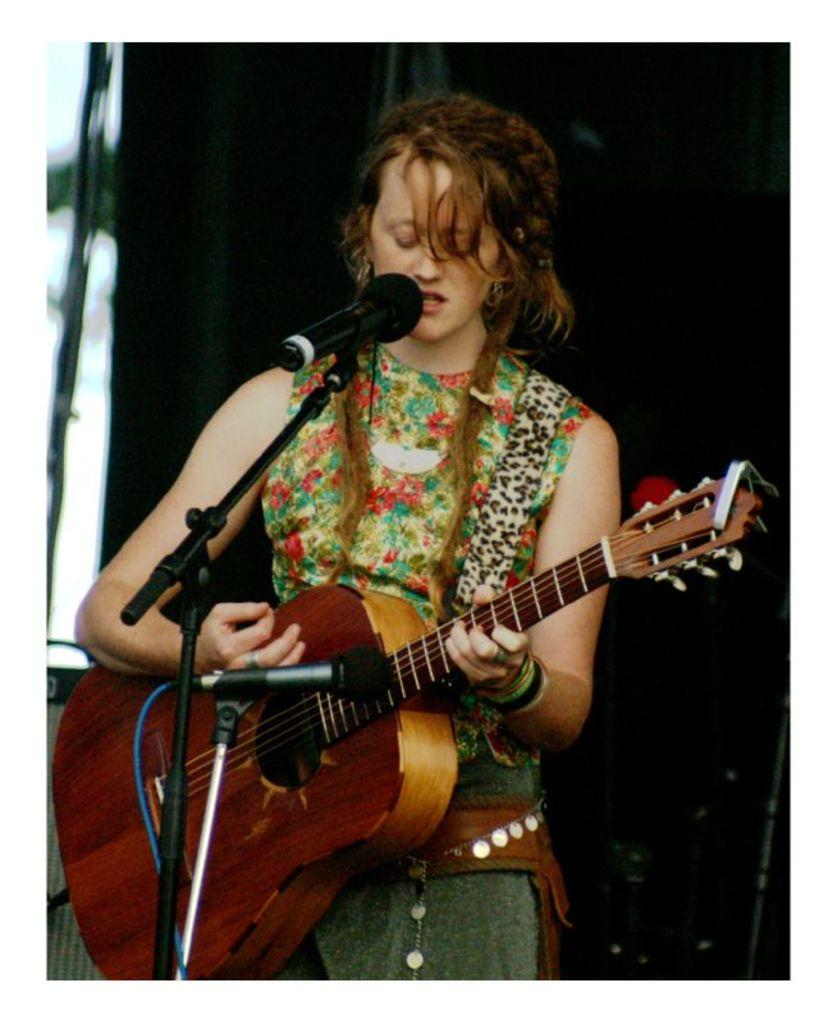What is the main subject of the image? The main subject of the image is a woman. What is the woman doing in the image? The woman is standing, singing, and playing the guitar. Is there any equipment attached to the guitar? Yes, there is a microphone attached to the guitar. What color is the woman's father's shirt in the image? There is no information about the woman's father or his shirt in the image. 